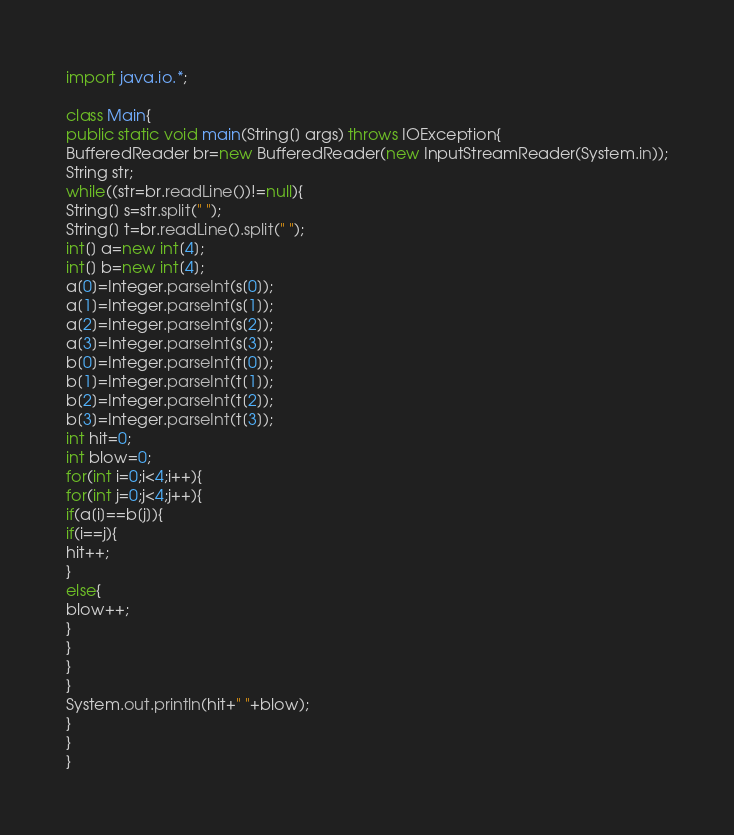Convert code to text. <code><loc_0><loc_0><loc_500><loc_500><_Java_>import java.io.*;

class Main{
public static void main(String[] args) throws IOException{
BufferedReader br=new BufferedReader(new InputStreamReader(System.in));
String str;
while((str=br.readLine())!=null){
String[] s=str.split(" ");
String[] t=br.readLine().split(" ");
int[] a=new int[4];
int[] b=new int[4];
a[0]=Integer.parseInt(s[0]);
a[1]=Integer.parseInt(s[1]);
a[2]=Integer.parseInt(s[2]);
a[3]=Integer.parseInt(s[3]);
b[0]=Integer.parseInt(t[0]);
b[1]=Integer.parseInt(t[1]);
b[2]=Integer.parseInt(t[2]);
b[3]=Integer.parseInt(t[3]);
int hit=0;
int blow=0;
for(int i=0;i<4;i++){
for(int j=0;j<4;j++){
if(a[i]==b[j]){
if(i==j){
hit++;
}
else{
blow++;
}
}
}
}
System.out.println(hit+" "+blow);
}
}
}</code> 